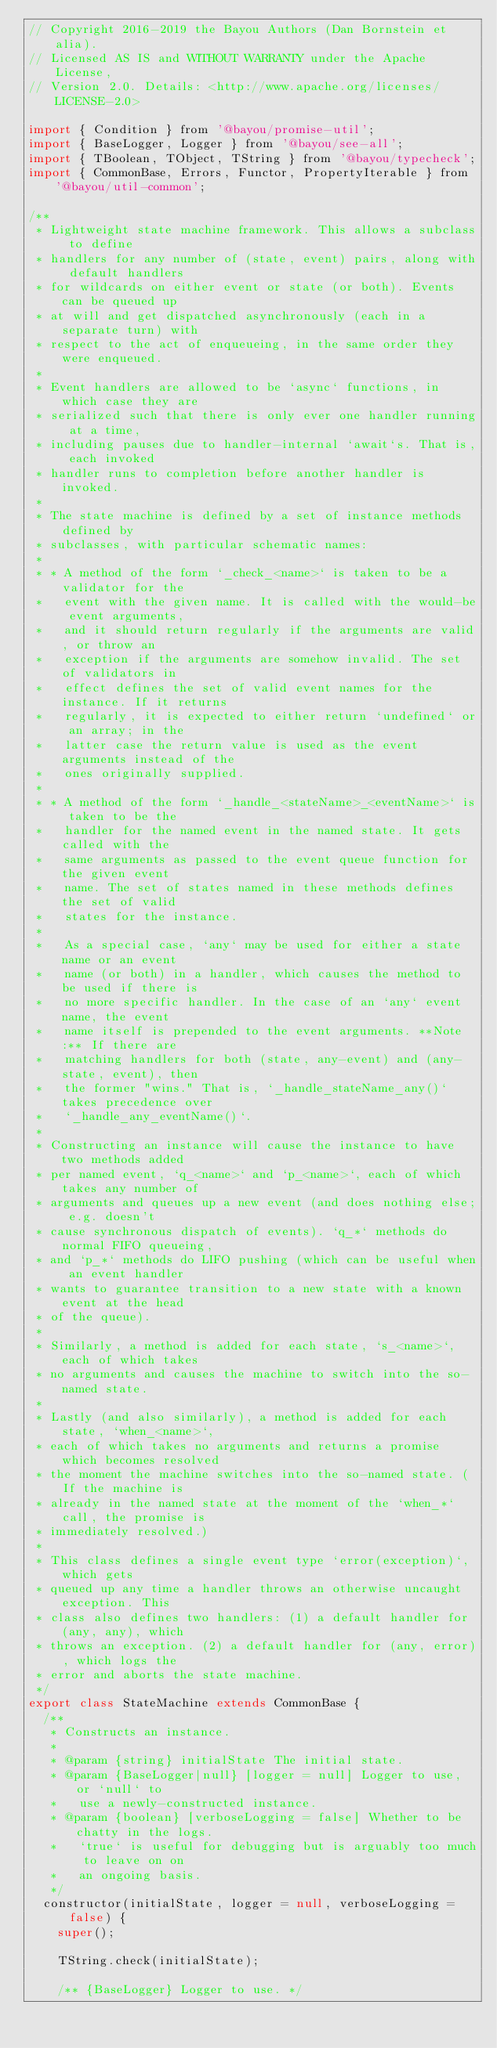Convert code to text. <code><loc_0><loc_0><loc_500><loc_500><_JavaScript_>// Copyright 2016-2019 the Bayou Authors (Dan Bornstein et alia).
// Licensed AS IS and WITHOUT WARRANTY under the Apache License,
// Version 2.0. Details: <http://www.apache.org/licenses/LICENSE-2.0>

import { Condition } from '@bayou/promise-util';
import { BaseLogger, Logger } from '@bayou/see-all';
import { TBoolean, TObject, TString } from '@bayou/typecheck';
import { CommonBase, Errors, Functor, PropertyIterable } from '@bayou/util-common';

/**
 * Lightweight state machine framework. This allows a subclass to define
 * handlers for any number of (state, event) pairs, along with default handlers
 * for wildcards on either event or state (or both). Events can be queued up
 * at will and get dispatched asynchronously (each in a separate turn) with
 * respect to the act of enqueueing, in the same order they were enqueued.
 *
 * Event handlers are allowed to be `async` functions, in which case they are
 * serialized such that there is only ever one handler running at a time,
 * including pauses due to handler-internal `await`s. That is, each invoked
 * handler runs to completion before another handler is invoked.
 *
 * The state machine is defined by a set of instance methods defined by
 * subclasses, with particular schematic names:
 *
 * * A method of the form `_check_<name>` is taken to be a validator for the
 *   event with the given name. It is called with the would-be event arguments,
 *   and it should return regularly if the arguments are valid, or throw an
 *   exception if the arguments are somehow invalid. The set of validators in
 *   effect defines the set of valid event names for the instance. If it returns
 *   regularly, it is expected to either return `undefined` or an array; in the
 *   latter case the return value is used as the event arguments instead of the
 *   ones originally supplied.
 *
 * * A method of the form `_handle_<stateName>_<eventName>` is taken to be the
 *   handler for the named event in the named state. It gets called with the
 *   same arguments as passed to the event queue function for the given event
 *   name. The set of states named in these methods defines the set of valid
 *   states for the instance.
 *
 *   As a special case, `any` may be used for either a state name or an event
 *   name (or both) in a handler, which causes the method to be used if there is
 *   no more specific handler. In the case of an `any` event name, the event
 *   name itself is prepended to the event arguments. **Note:** If there are
 *   matching handlers for both (state, any-event) and (any-state, event), then
 *   the former "wins." That is, `_handle_stateName_any()` takes precedence over
 *   `_handle_any_eventName()`.
 *
 * Constructing an instance will cause the instance to have two methods added
 * per named event, `q_<name>` and `p_<name>`, each of which takes any number of
 * arguments and queues up a new event (and does nothing else; e.g. doesn't
 * cause synchronous dispatch of events). `q_*` methods do normal FIFO queueing,
 * and `p_*` methods do LIFO pushing (which can be useful when an event handler
 * wants to guarantee transition to a new state with a known event at the head
 * of the queue).
 *
 * Similarly, a method is added for each state, `s_<name>`, each of which takes
 * no arguments and causes the machine to switch into the so-named state.
 *
 * Lastly (and also similarly), a method is added for each state, `when_<name>`,
 * each of which takes no arguments and returns a promise which becomes resolved
 * the moment the machine switches into the so-named state. (If the machine is
 * already in the named state at the moment of the `when_*` call, the promise is
 * immediately resolved.)
 *
 * This class defines a single event type `error(exception)`, which gets
 * queued up any time a handler throws an otherwise uncaught exception. This
 * class also defines two handlers: (1) a default handler for (any, any), which
 * throws an exception. (2) a default handler for (any, error), which logs the
 * error and aborts the state machine.
 */
export class StateMachine extends CommonBase {
  /**
   * Constructs an instance.
   *
   * @param {string} initialState The initial state.
   * @param {BaseLogger|null} [logger = null] Logger to use, or `null` to
   *   use a newly-constructed instance.
   * @param {boolean} [verboseLogging = false] Whether to be chatty in the logs.
   *   `true` is useful for debugging but is arguably too much to leave on on
   *   an ongoing basis.
   */
  constructor(initialState, logger = null, verboseLogging = false) {
    super();

    TString.check(initialState);

    /** {BaseLogger} Logger to use. */</code> 